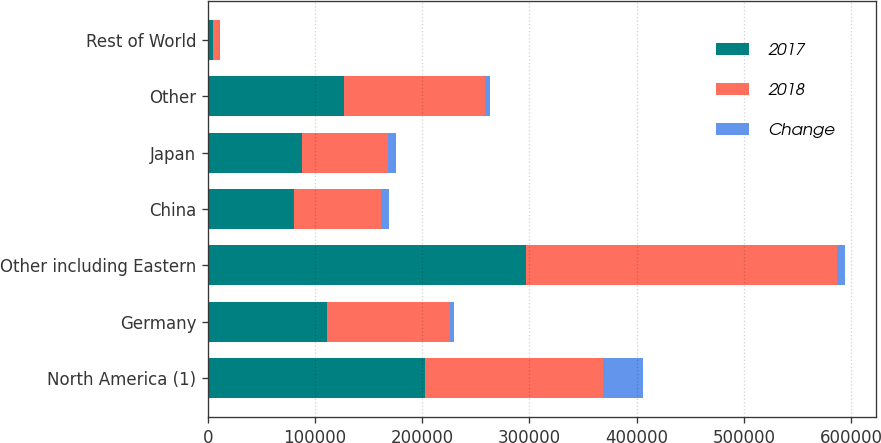<chart> <loc_0><loc_0><loc_500><loc_500><stacked_bar_chart><ecel><fcel>North America (1)<fcel>Germany<fcel>Other including Eastern<fcel>China<fcel>Japan<fcel>Other<fcel>Rest of World<nl><fcel>2017<fcel>202743<fcel>111259<fcel>296917<fcel>80612<fcel>87619<fcel>127251<fcel>5006<nl><fcel>2018<fcel>165363<fcel>114608<fcel>290067<fcel>80612<fcel>80612<fcel>131511<fcel>5445<nl><fcel>Change<fcel>37380<fcel>3349<fcel>6850<fcel>7796<fcel>7007<fcel>4260<fcel>439<nl></chart> 